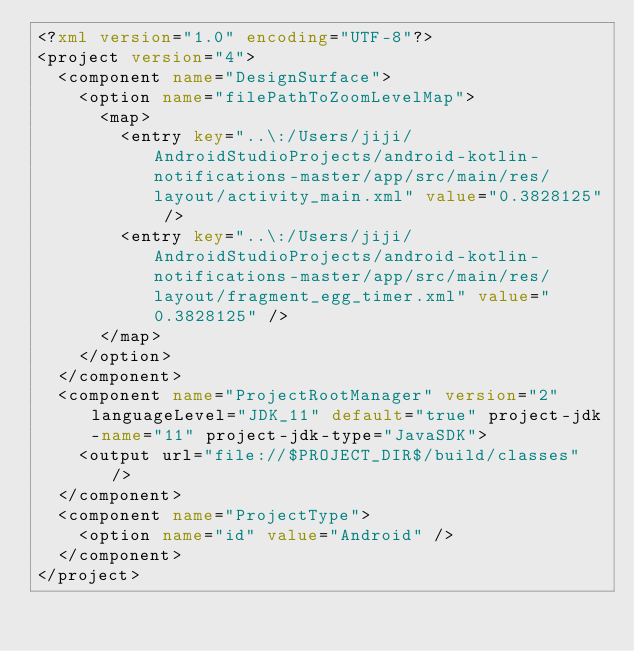<code> <loc_0><loc_0><loc_500><loc_500><_XML_><?xml version="1.0" encoding="UTF-8"?>
<project version="4">
  <component name="DesignSurface">
    <option name="filePathToZoomLevelMap">
      <map>
        <entry key="..\:/Users/jiji/AndroidStudioProjects/android-kotlin-notifications-master/app/src/main/res/layout/activity_main.xml" value="0.3828125" />
        <entry key="..\:/Users/jiji/AndroidStudioProjects/android-kotlin-notifications-master/app/src/main/res/layout/fragment_egg_timer.xml" value="0.3828125" />
      </map>
    </option>
  </component>
  <component name="ProjectRootManager" version="2" languageLevel="JDK_11" default="true" project-jdk-name="11" project-jdk-type="JavaSDK">
    <output url="file://$PROJECT_DIR$/build/classes" />
  </component>
  <component name="ProjectType">
    <option name="id" value="Android" />
  </component>
</project></code> 